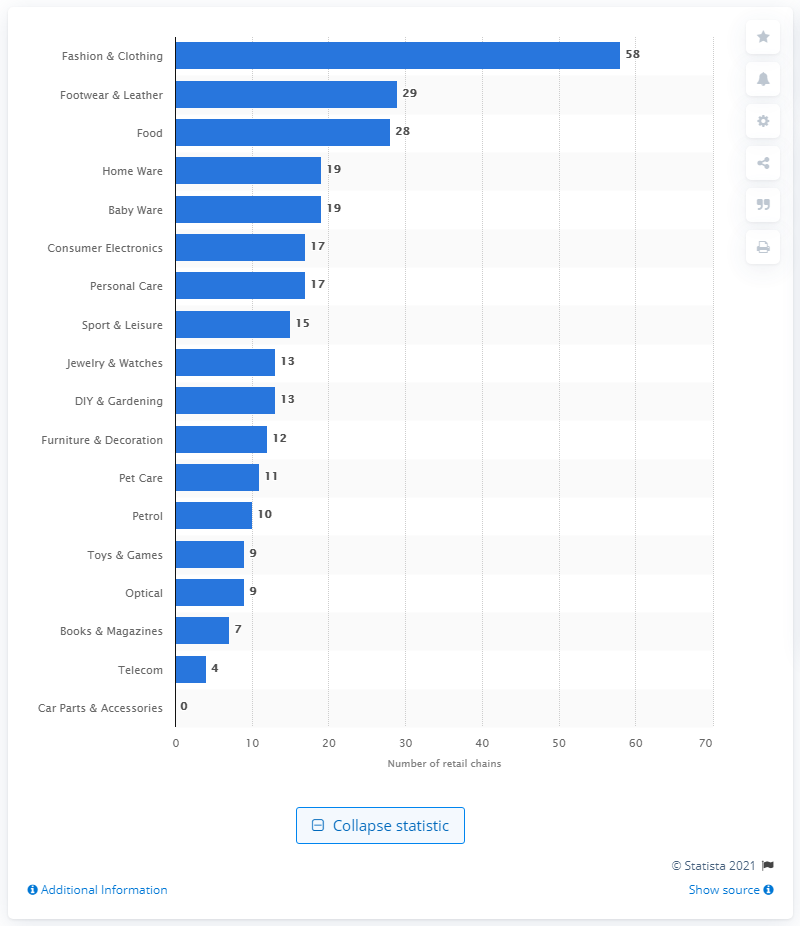List a handful of essential elements in this visual. As of October 2020, the leather and footwear sector accounted for 29 retail chains. 